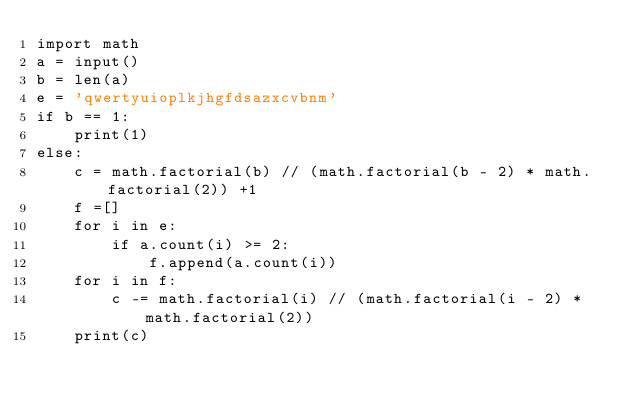<code> <loc_0><loc_0><loc_500><loc_500><_Python_>import math
a = input()
b = len(a)
e = 'qwertyuioplkjhgfdsazxcvbnm'
if b == 1:
    print(1)
else:
    c = math.factorial(b) // (math.factorial(b - 2) * math.factorial(2)) +1
    f =[]
    for i in e:
        if a.count(i) >= 2:
            f.append(a.count(i))
    for i in f:
        c -= math.factorial(i) // (math.factorial(i - 2) * math.factorial(2))
    print(c)</code> 